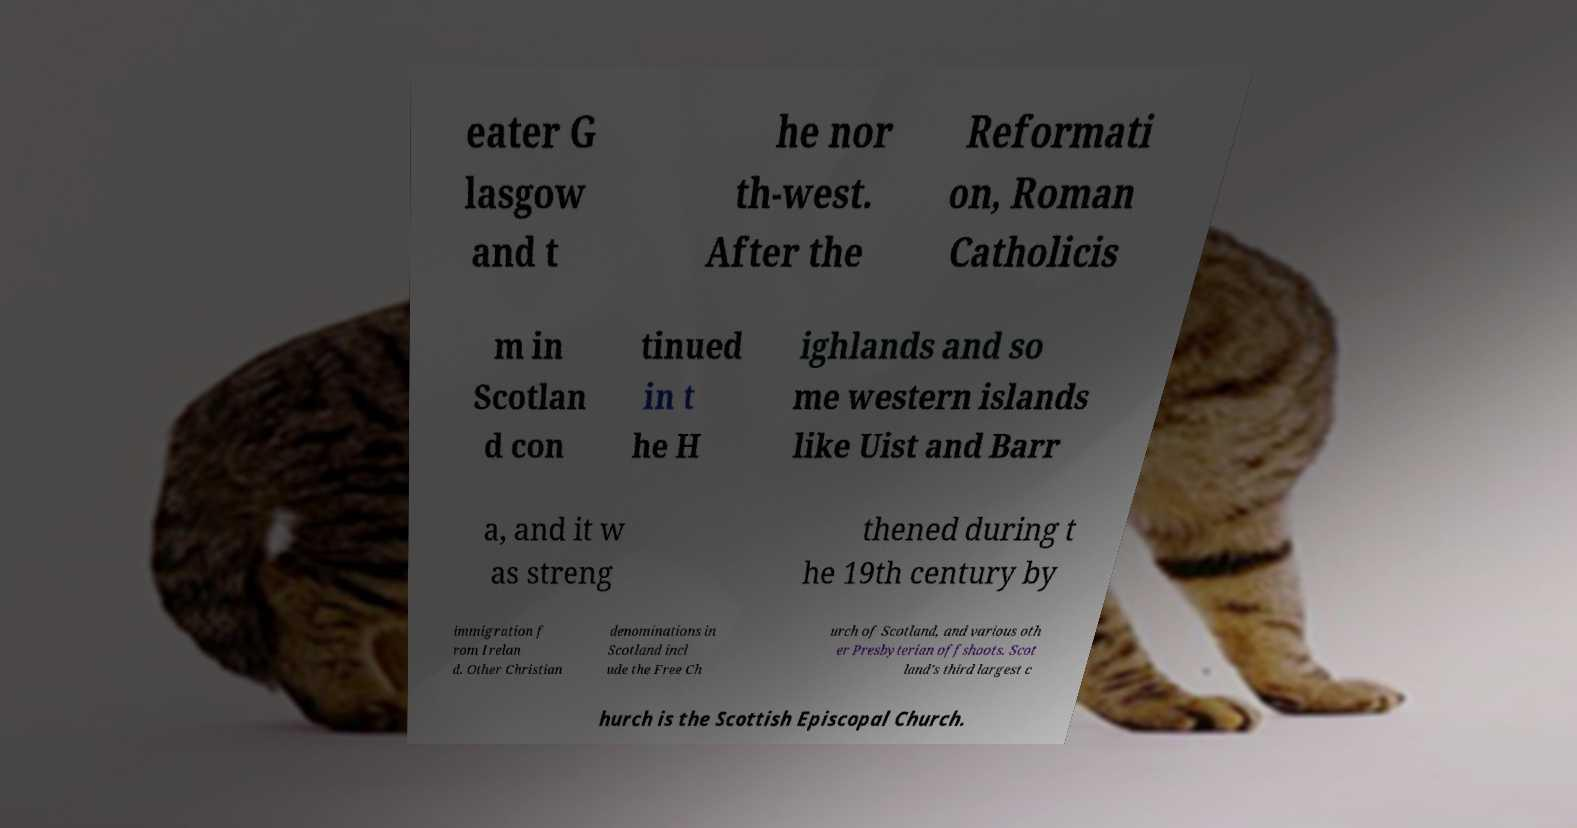Can you read and provide the text displayed in the image?This photo seems to have some interesting text. Can you extract and type it out for me? eater G lasgow and t he nor th-west. After the Reformati on, Roman Catholicis m in Scotlan d con tinued in t he H ighlands and so me western islands like Uist and Barr a, and it w as streng thened during t he 19th century by immigration f rom Irelan d. Other Christian denominations in Scotland incl ude the Free Ch urch of Scotland, and various oth er Presbyterian offshoots. Scot land's third largest c hurch is the Scottish Episcopal Church. 